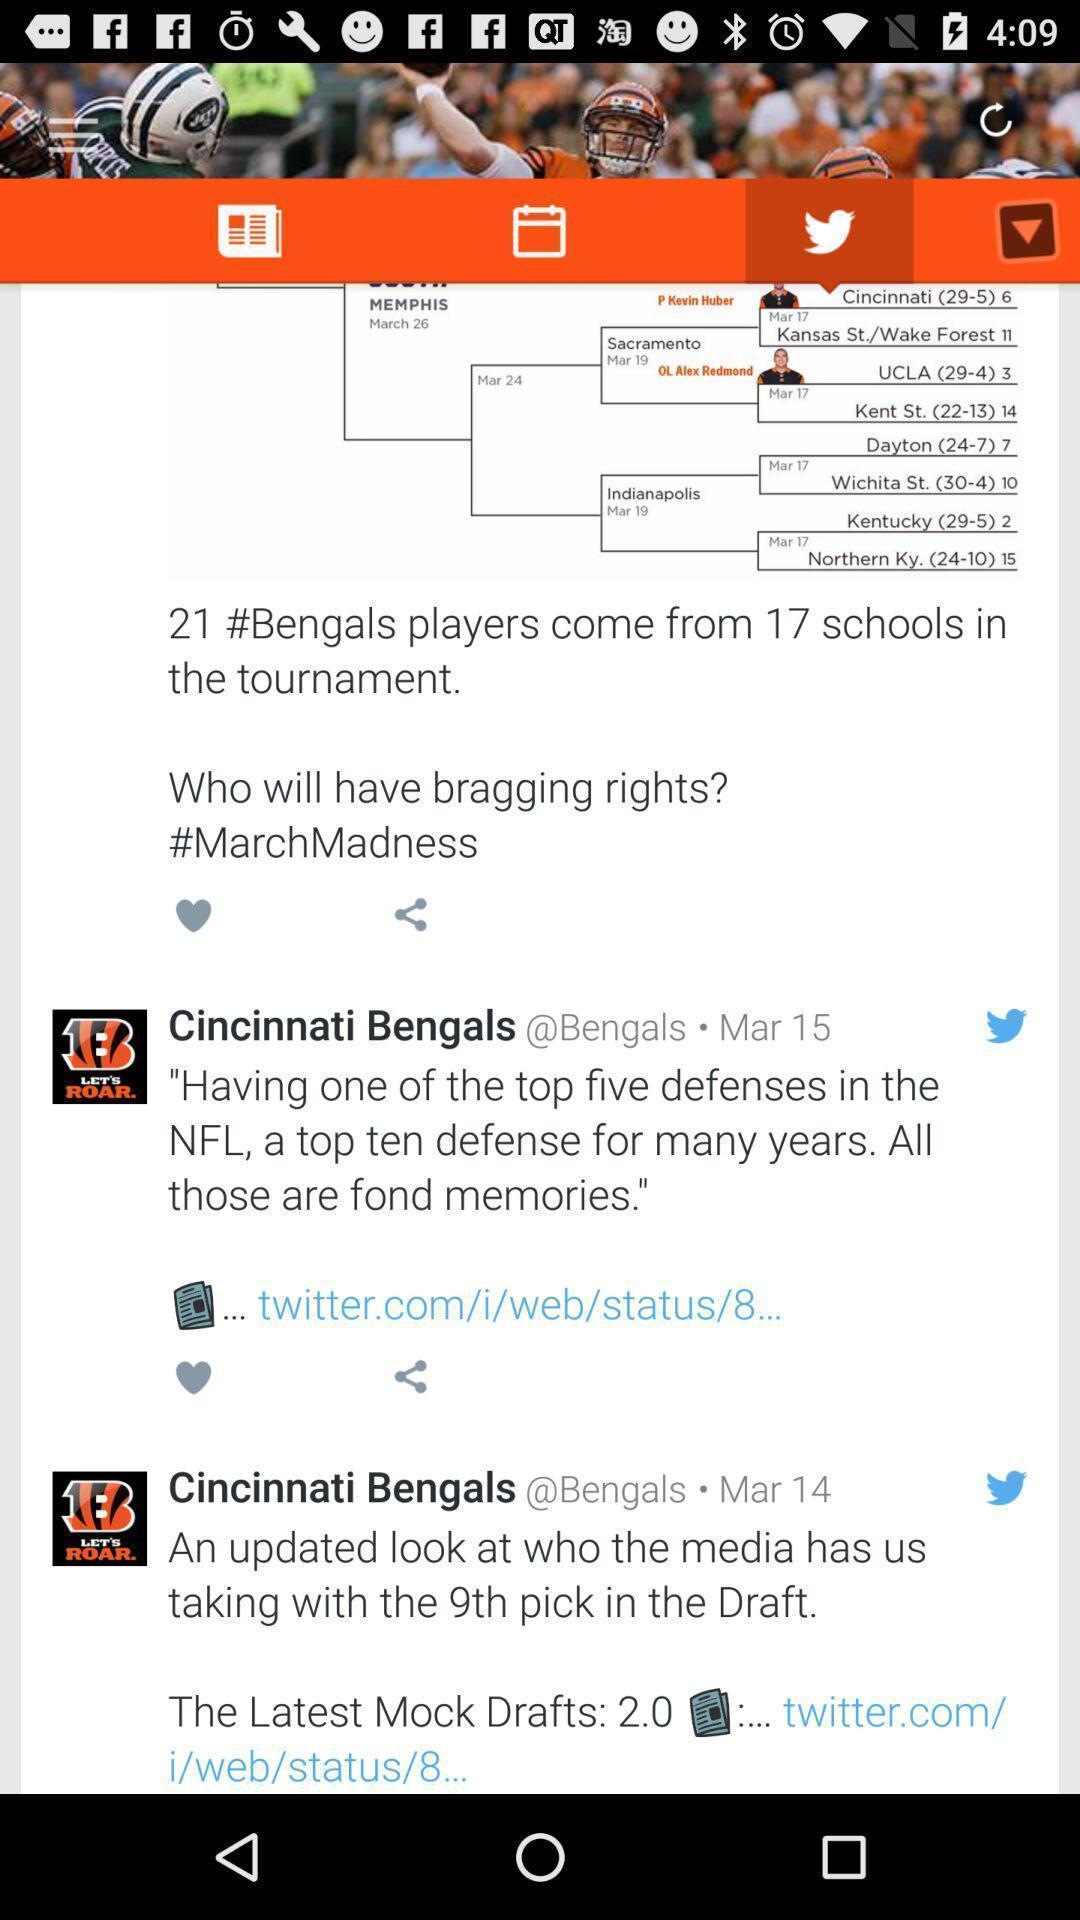Describe the content in this image. Page showing various posts in social media app. 